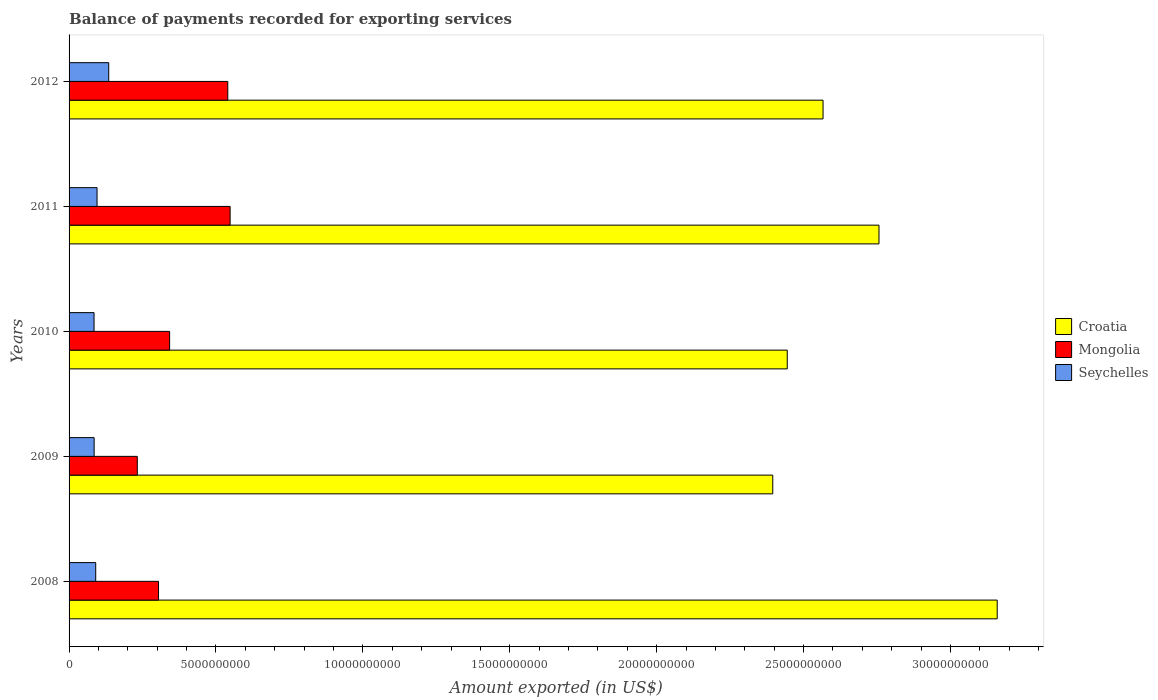How many different coloured bars are there?
Your answer should be very brief. 3. How many groups of bars are there?
Offer a terse response. 5. Are the number of bars per tick equal to the number of legend labels?
Keep it short and to the point. Yes. Are the number of bars on each tick of the Y-axis equal?
Your response must be concise. Yes. How many bars are there on the 2nd tick from the bottom?
Give a very brief answer. 3. In how many cases, is the number of bars for a given year not equal to the number of legend labels?
Offer a terse response. 0. What is the amount exported in Mongolia in 2009?
Offer a terse response. 2.32e+09. Across all years, what is the maximum amount exported in Seychelles?
Your answer should be compact. 1.35e+09. Across all years, what is the minimum amount exported in Seychelles?
Provide a succinct answer. 8.50e+08. What is the total amount exported in Croatia in the graph?
Offer a terse response. 1.33e+11. What is the difference between the amount exported in Mongolia in 2008 and that in 2011?
Provide a short and direct response. -2.44e+09. What is the difference between the amount exported in Croatia in 2009 and the amount exported in Mongolia in 2008?
Your answer should be very brief. 2.09e+1. What is the average amount exported in Mongolia per year?
Your answer should be very brief. 3.93e+09. In the year 2009, what is the difference between the amount exported in Croatia and amount exported in Seychelles?
Give a very brief answer. 2.31e+1. In how many years, is the amount exported in Seychelles greater than 4000000000 US$?
Ensure brevity in your answer.  0. What is the ratio of the amount exported in Croatia in 2009 to that in 2011?
Provide a succinct answer. 0.87. Is the amount exported in Seychelles in 2009 less than that in 2011?
Your answer should be very brief. Yes. Is the difference between the amount exported in Croatia in 2009 and 2010 greater than the difference between the amount exported in Seychelles in 2009 and 2010?
Offer a very short reply. No. What is the difference between the highest and the second highest amount exported in Mongolia?
Your answer should be very brief. 7.94e+07. What is the difference between the highest and the lowest amount exported in Seychelles?
Ensure brevity in your answer.  5.00e+08. In how many years, is the amount exported in Croatia greater than the average amount exported in Croatia taken over all years?
Your answer should be compact. 2. What does the 1st bar from the top in 2011 represents?
Offer a very short reply. Seychelles. What does the 2nd bar from the bottom in 2010 represents?
Make the answer very short. Mongolia. How many bars are there?
Your answer should be compact. 15. How many years are there in the graph?
Ensure brevity in your answer.  5. What is the difference between two consecutive major ticks on the X-axis?
Give a very brief answer. 5.00e+09. How are the legend labels stacked?
Offer a very short reply. Vertical. What is the title of the graph?
Provide a short and direct response. Balance of payments recorded for exporting services. What is the label or title of the X-axis?
Make the answer very short. Amount exported (in US$). What is the label or title of the Y-axis?
Provide a succinct answer. Years. What is the Amount exported (in US$) of Croatia in 2008?
Provide a short and direct response. 3.16e+1. What is the Amount exported (in US$) of Mongolia in 2008?
Ensure brevity in your answer.  3.05e+09. What is the Amount exported (in US$) of Seychelles in 2008?
Keep it short and to the point. 9.07e+08. What is the Amount exported (in US$) in Croatia in 2009?
Offer a terse response. 2.40e+1. What is the Amount exported (in US$) of Mongolia in 2009?
Provide a short and direct response. 2.32e+09. What is the Amount exported (in US$) of Seychelles in 2009?
Provide a succinct answer. 8.53e+08. What is the Amount exported (in US$) in Croatia in 2010?
Provide a short and direct response. 2.44e+1. What is the Amount exported (in US$) of Mongolia in 2010?
Offer a terse response. 3.42e+09. What is the Amount exported (in US$) in Seychelles in 2010?
Ensure brevity in your answer.  8.50e+08. What is the Amount exported (in US$) in Croatia in 2011?
Your response must be concise. 2.76e+1. What is the Amount exported (in US$) of Mongolia in 2011?
Offer a terse response. 5.48e+09. What is the Amount exported (in US$) in Seychelles in 2011?
Offer a very short reply. 9.52e+08. What is the Amount exported (in US$) in Croatia in 2012?
Your answer should be very brief. 2.57e+1. What is the Amount exported (in US$) of Mongolia in 2012?
Offer a very short reply. 5.40e+09. What is the Amount exported (in US$) of Seychelles in 2012?
Offer a very short reply. 1.35e+09. Across all years, what is the maximum Amount exported (in US$) in Croatia?
Offer a very short reply. 3.16e+1. Across all years, what is the maximum Amount exported (in US$) in Mongolia?
Give a very brief answer. 5.48e+09. Across all years, what is the maximum Amount exported (in US$) in Seychelles?
Your answer should be compact. 1.35e+09. Across all years, what is the minimum Amount exported (in US$) of Croatia?
Provide a short and direct response. 2.40e+1. Across all years, what is the minimum Amount exported (in US$) of Mongolia?
Your answer should be very brief. 2.32e+09. Across all years, what is the minimum Amount exported (in US$) in Seychelles?
Give a very brief answer. 8.50e+08. What is the total Amount exported (in US$) in Croatia in the graph?
Make the answer very short. 1.33e+11. What is the total Amount exported (in US$) of Mongolia in the graph?
Give a very brief answer. 1.97e+1. What is the total Amount exported (in US$) in Seychelles in the graph?
Your answer should be very brief. 4.91e+09. What is the difference between the Amount exported (in US$) in Croatia in 2008 and that in 2009?
Your response must be concise. 7.64e+09. What is the difference between the Amount exported (in US$) in Mongolia in 2008 and that in 2009?
Offer a very short reply. 7.23e+08. What is the difference between the Amount exported (in US$) in Seychelles in 2008 and that in 2009?
Provide a short and direct response. 5.35e+07. What is the difference between the Amount exported (in US$) in Croatia in 2008 and that in 2010?
Give a very brief answer. 7.15e+09. What is the difference between the Amount exported (in US$) in Mongolia in 2008 and that in 2010?
Ensure brevity in your answer.  -3.78e+08. What is the difference between the Amount exported (in US$) in Seychelles in 2008 and that in 2010?
Your answer should be compact. 5.66e+07. What is the difference between the Amount exported (in US$) of Croatia in 2008 and that in 2011?
Your response must be concise. 4.02e+09. What is the difference between the Amount exported (in US$) of Mongolia in 2008 and that in 2011?
Your answer should be compact. -2.44e+09. What is the difference between the Amount exported (in US$) in Seychelles in 2008 and that in 2011?
Give a very brief answer. -4.55e+07. What is the difference between the Amount exported (in US$) in Croatia in 2008 and that in 2012?
Make the answer very short. 5.93e+09. What is the difference between the Amount exported (in US$) in Mongolia in 2008 and that in 2012?
Ensure brevity in your answer.  -2.36e+09. What is the difference between the Amount exported (in US$) in Seychelles in 2008 and that in 2012?
Ensure brevity in your answer.  -4.43e+08. What is the difference between the Amount exported (in US$) in Croatia in 2009 and that in 2010?
Your answer should be compact. -4.93e+08. What is the difference between the Amount exported (in US$) in Mongolia in 2009 and that in 2010?
Make the answer very short. -1.10e+09. What is the difference between the Amount exported (in US$) of Seychelles in 2009 and that in 2010?
Give a very brief answer. 3.12e+06. What is the difference between the Amount exported (in US$) of Croatia in 2009 and that in 2011?
Your answer should be very brief. -3.62e+09. What is the difference between the Amount exported (in US$) in Mongolia in 2009 and that in 2011?
Offer a very short reply. -3.16e+09. What is the difference between the Amount exported (in US$) in Seychelles in 2009 and that in 2011?
Provide a succinct answer. -9.90e+07. What is the difference between the Amount exported (in US$) of Croatia in 2009 and that in 2012?
Offer a very short reply. -1.71e+09. What is the difference between the Amount exported (in US$) of Mongolia in 2009 and that in 2012?
Offer a terse response. -3.08e+09. What is the difference between the Amount exported (in US$) of Seychelles in 2009 and that in 2012?
Give a very brief answer. -4.97e+08. What is the difference between the Amount exported (in US$) of Croatia in 2010 and that in 2011?
Ensure brevity in your answer.  -3.12e+09. What is the difference between the Amount exported (in US$) of Mongolia in 2010 and that in 2011?
Provide a succinct answer. -2.06e+09. What is the difference between the Amount exported (in US$) in Seychelles in 2010 and that in 2011?
Offer a terse response. -1.02e+08. What is the difference between the Amount exported (in US$) of Croatia in 2010 and that in 2012?
Keep it short and to the point. -1.22e+09. What is the difference between the Amount exported (in US$) of Mongolia in 2010 and that in 2012?
Your answer should be very brief. -1.98e+09. What is the difference between the Amount exported (in US$) of Seychelles in 2010 and that in 2012?
Provide a succinct answer. -5.00e+08. What is the difference between the Amount exported (in US$) of Croatia in 2011 and that in 2012?
Your answer should be very brief. 1.90e+09. What is the difference between the Amount exported (in US$) of Mongolia in 2011 and that in 2012?
Ensure brevity in your answer.  7.94e+07. What is the difference between the Amount exported (in US$) of Seychelles in 2011 and that in 2012?
Provide a short and direct response. -3.98e+08. What is the difference between the Amount exported (in US$) in Croatia in 2008 and the Amount exported (in US$) in Mongolia in 2009?
Make the answer very short. 2.93e+1. What is the difference between the Amount exported (in US$) in Croatia in 2008 and the Amount exported (in US$) in Seychelles in 2009?
Offer a very short reply. 3.07e+1. What is the difference between the Amount exported (in US$) in Mongolia in 2008 and the Amount exported (in US$) in Seychelles in 2009?
Offer a very short reply. 2.19e+09. What is the difference between the Amount exported (in US$) in Croatia in 2008 and the Amount exported (in US$) in Mongolia in 2010?
Your answer should be very brief. 2.82e+1. What is the difference between the Amount exported (in US$) in Croatia in 2008 and the Amount exported (in US$) in Seychelles in 2010?
Provide a succinct answer. 3.07e+1. What is the difference between the Amount exported (in US$) in Mongolia in 2008 and the Amount exported (in US$) in Seychelles in 2010?
Offer a terse response. 2.19e+09. What is the difference between the Amount exported (in US$) of Croatia in 2008 and the Amount exported (in US$) of Mongolia in 2011?
Make the answer very short. 2.61e+1. What is the difference between the Amount exported (in US$) of Croatia in 2008 and the Amount exported (in US$) of Seychelles in 2011?
Provide a succinct answer. 3.06e+1. What is the difference between the Amount exported (in US$) of Mongolia in 2008 and the Amount exported (in US$) of Seychelles in 2011?
Your response must be concise. 2.09e+09. What is the difference between the Amount exported (in US$) in Croatia in 2008 and the Amount exported (in US$) in Mongolia in 2012?
Make the answer very short. 2.62e+1. What is the difference between the Amount exported (in US$) of Croatia in 2008 and the Amount exported (in US$) of Seychelles in 2012?
Ensure brevity in your answer.  3.02e+1. What is the difference between the Amount exported (in US$) in Mongolia in 2008 and the Amount exported (in US$) in Seychelles in 2012?
Keep it short and to the point. 1.69e+09. What is the difference between the Amount exported (in US$) of Croatia in 2009 and the Amount exported (in US$) of Mongolia in 2010?
Give a very brief answer. 2.05e+1. What is the difference between the Amount exported (in US$) in Croatia in 2009 and the Amount exported (in US$) in Seychelles in 2010?
Keep it short and to the point. 2.31e+1. What is the difference between the Amount exported (in US$) in Mongolia in 2009 and the Amount exported (in US$) in Seychelles in 2010?
Offer a terse response. 1.47e+09. What is the difference between the Amount exported (in US$) in Croatia in 2009 and the Amount exported (in US$) in Mongolia in 2011?
Provide a succinct answer. 1.85e+1. What is the difference between the Amount exported (in US$) in Croatia in 2009 and the Amount exported (in US$) in Seychelles in 2011?
Make the answer very short. 2.30e+1. What is the difference between the Amount exported (in US$) in Mongolia in 2009 and the Amount exported (in US$) in Seychelles in 2011?
Provide a succinct answer. 1.37e+09. What is the difference between the Amount exported (in US$) of Croatia in 2009 and the Amount exported (in US$) of Mongolia in 2012?
Provide a short and direct response. 1.86e+1. What is the difference between the Amount exported (in US$) in Croatia in 2009 and the Amount exported (in US$) in Seychelles in 2012?
Give a very brief answer. 2.26e+1. What is the difference between the Amount exported (in US$) in Mongolia in 2009 and the Amount exported (in US$) in Seychelles in 2012?
Provide a short and direct response. 9.72e+08. What is the difference between the Amount exported (in US$) of Croatia in 2010 and the Amount exported (in US$) of Mongolia in 2011?
Your answer should be compact. 1.90e+1. What is the difference between the Amount exported (in US$) of Croatia in 2010 and the Amount exported (in US$) of Seychelles in 2011?
Keep it short and to the point. 2.35e+1. What is the difference between the Amount exported (in US$) in Mongolia in 2010 and the Amount exported (in US$) in Seychelles in 2011?
Keep it short and to the point. 2.47e+09. What is the difference between the Amount exported (in US$) of Croatia in 2010 and the Amount exported (in US$) of Mongolia in 2012?
Give a very brief answer. 1.90e+1. What is the difference between the Amount exported (in US$) of Croatia in 2010 and the Amount exported (in US$) of Seychelles in 2012?
Keep it short and to the point. 2.31e+1. What is the difference between the Amount exported (in US$) in Mongolia in 2010 and the Amount exported (in US$) in Seychelles in 2012?
Your answer should be very brief. 2.07e+09. What is the difference between the Amount exported (in US$) in Croatia in 2011 and the Amount exported (in US$) in Mongolia in 2012?
Provide a succinct answer. 2.22e+1. What is the difference between the Amount exported (in US$) in Croatia in 2011 and the Amount exported (in US$) in Seychelles in 2012?
Provide a short and direct response. 2.62e+1. What is the difference between the Amount exported (in US$) of Mongolia in 2011 and the Amount exported (in US$) of Seychelles in 2012?
Give a very brief answer. 4.13e+09. What is the average Amount exported (in US$) in Croatia per year?
Your answer should be compact. 2.66e+1. What is the average Amount exported (in US$) of Mongolia per year?
Your answer should be very brief. 3.93e+09. What is the average Amount exported (in US$) in Seychelles per year?
Ensure brevity in your answer.  9.83e+08. In the year 2008, what is the difference between the Amount exported (in US$) in Croatia and Amount exported (in US$) in Mongolia?
Ensure brevity in your answer.  2.85e+1. In the year 2008, what is the difference between the Amount exported (in US$) in Croatia and Amount exported (in US$) in Seychelles?
Give a very brief answer. 3.07e+1. In the year 2008, what is the difference between the Amount exported (in US$) in Mongolia and Amount exported (in US$) in Seychelles?
Offer a terse response. 2.14e+09. In the year 2009, what is the difference between the Amount exported (in US$) of Croatia and Amount exported (in US$) of Mongolia?
Ensure brevity in your answer.  2.16e+1. In the year 2009, what is the difference between the Amount exported (in US$) in Croatia and Amount exported (in US$) in Seychelles?
Keep it short and to the point. 2.31e+1. In the year 2009, what is the difference between the Amount exported (in US$) of Mongolia and Amount exported (in US$) of Seychelles?
Your answer should be compact. 1.47e+09. In the year 2010, what is the difference between the Amount exported (in US$) in Croatia and Amount exported (in US$) in Mongolia?
Provide a short and direct response. 2.10e+1. In the year 2010, what is the difference between the Amount exported (in US$) in Croatia and Amount exported (in US$) in Seychelles?
Offer a terse response. 2.36e+1. In the year 2010, what is the difference between the Amount exported (in US$) of Mongolia and Amount exported (in US$) of Seychelles?
Provide a succinct answer. 2.57e+09. In the year 2011, what is the difference between the Amount exported (in US$) of Croatia and Amount exported (in US$) of Mongolia?
Your answer should be very brief. 2.21e+1. In the year 2011, what is the difference between the Amount exported (in US$) in Croatia and Amount exported (in US$) in Seychelles?
Make the answer very short. 2.66e+1. In the year 2011, what is the difference between the Amount exported (in US$) of Mongolia and Amount exported (in US$) of Seychelles?
Give a very brief answer. 4.53e+09. In the year 2012, what is the difference between the Amount exported (in US$) in Croatia and Amount exported (in US$) in Mongolia?
Offer a very short reply. 2.03e+1. In the year 2012, what is the difference between the Amount exported (in US$) in Croatia and Amount exported (in US$) in Seychelles?
Provide a short and direct response. 2.43e+1. In the year 2012, what is the difference between the Amount exported (in US$) in Mongolia and Amount exported (in US$) in Seychelles?
Give a very brief answer. 4.05e+09. What is the ratio of the Amount exported (in US$) of Croatia in 2008 to that in 2009?
Ensure brevity in your answer.  1.32. What is the ratio of the Amount exported (in US$) of Mongolia in 2008 to that in 2009?
Keep it short and to the point. 1.31. What is the ratio of the Amount exported (in US$) of Seychelles in 2008 to that in 2009?
Offer a terse response. 1.06. What is the ratio of the Amount exported (in US$) in Croatia in 2008 to that in 2010?
Offer a terse response. 1.29. What is the ratio of the Amount exported (in US$) of Mongolia in 2008 to that in 2010?
Your answer should be compact. 0.89. What is the ratio of the Amount exported (in US$) in Seychelles in 2008 to that in 2010?
Your answer should be compact. 1.07. What is the ratio of the Amount exported (in US$) of Croatia in 2008 to that in 2011?
Offer a very short reply. 1.15. What is the ratio of the Amount exported (in US$) in Mongolia in 2008 to that in 2011?
Make the answer very short. 0.56. What is the ratio of the Amount exported (in US$) of Seychelles in 2008 to that in 2011?
Give a very brief answer. 0.95. What is the ratio of the Amount exported (in US$) in Croatia in 2008 to that in 2012?
Keep it short and to the point. 1.23. What is the ratio of the Amount exported (in US$) in Mongolia in 2008 to that in 2012?
Ensure brevity in your answer.  0.56. What is the ratio of the Amount exported (in US$) in Seychelles in 2008 to that in 2012?
Your answer should be compact. 0.67. What is the ratio of the Amount exported (in US$) in Croatia in 2009 to that in 2010?
Ensure brevity in your answer.  0.98. What is the ratio of the Amount exported (in US$) in Mongolia in 2009 to that in 2010?
Provide a short and direct response. 0.68. What is the ratio of the Amount exported (in US$) in Croatia in 2009 to that in 2011?
Ensure brevity in your answer.  0.87. What is the ratio of the Amount exported (in US$) in Mongolia in 2009 to that in 2011?
Your response must be concise. 0.42. What is the ratio of the Amount exported (in US$) of Seychelles in 2009 to that in 2011?
Give a very brief answer. 0.9. What is the ratio of the Amount exported (in US$) of Croatia in 2009 to that in 2012?
Give a very brief answer. 0.93. What is the ratio of the Amount exported (in US$) of Mongolia in 2009 to that in 2012?
Your answer should be very brief. 0.43. What is the ratio of the Amount exported (in US$) of Seychelles in 2009 to that in 2012?
Make the answer very short. 0.63. What is the ratio of the Amount exported (in US$) in Croatia in 2010 to that in 2011?
Keep it short and to the point. 0.89. What is the ratio of the Amount exported (in US$) of Mongolia in 2010 to that in 2011?
Provide a short and direct response. 0.62. What is the ratio of the Amount exported (in US$) of Seychelles in 2010 to that in 2011?
Provide a succinct answer. 0.89. What is the ratio of the Amount exported (in US$) in Croatia in 2010 to that in 2012?
Provide a succinct answer. 0.95. What is the ratio of the Amount exported (in US$) of Mongolia in 2010 to that in 2012?
Provide a succinct answer. 0.63. What is the ratio of the Amount exported (in US$) of Seychelles in 2010 to that in 2012?
Give a very brief answer. 0.63. What is the ratio of the Amount exported (in US$) in Croatia in 2011 to that in 2012?
Give a very brief answer. 1.07. What is the ratio of the Amount exported (in US$) in Mongolia in 2011 to that in 2012?
Provide a short and direct response. 1.01. What is the ratio of the Amount exported (in US$) of Seychelles in 2011 to that in 2012?
Offer a terse response. 0.71. What is the difference between the highest and the second highest Amount exported (in US$) of Croatia?
Offer a very short reply. 4.02e+09. What is the difference between the highest and the second highest Amount exported (in US$) in Mongolia?
Provide a short and direct response. 7.94e+07. What is the difference between the highest and the second highest Amount exported (in US$) of Seychelles?
Ensure brevity in your answer.  3.98e+08. What is the difference between the highest and the lowest Amount exported (in US$) in Croatia?
Ensure brevity in your answer.  7.64e+09. What is the difference between the highest and the lowest Amount exported (in US$) of Mongolia?
Provide a short and direct response. 3.16e+09. What is the difference between the highest and the lowest Amount exported (in US$) in Seychelles?
Your answer should be compact. 5.00e+08. 